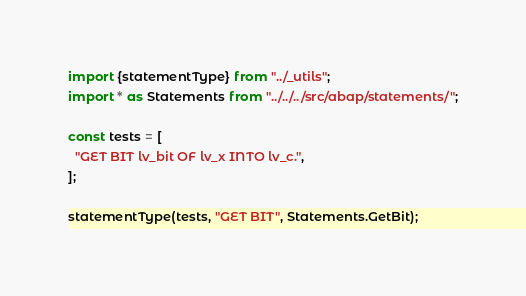<code> <loc_0><loc_0><loc_500><loc_500><_TypeScript_>import {statementType} from "../_utils";
import * as Statements from "../../../src/abap/statements/";

const tests = [
  "GET BIT lv_bit OF lv_x INTO lv_c.",
];

statementType(tests, "GET BIT", Statements.GetBit);</code> 